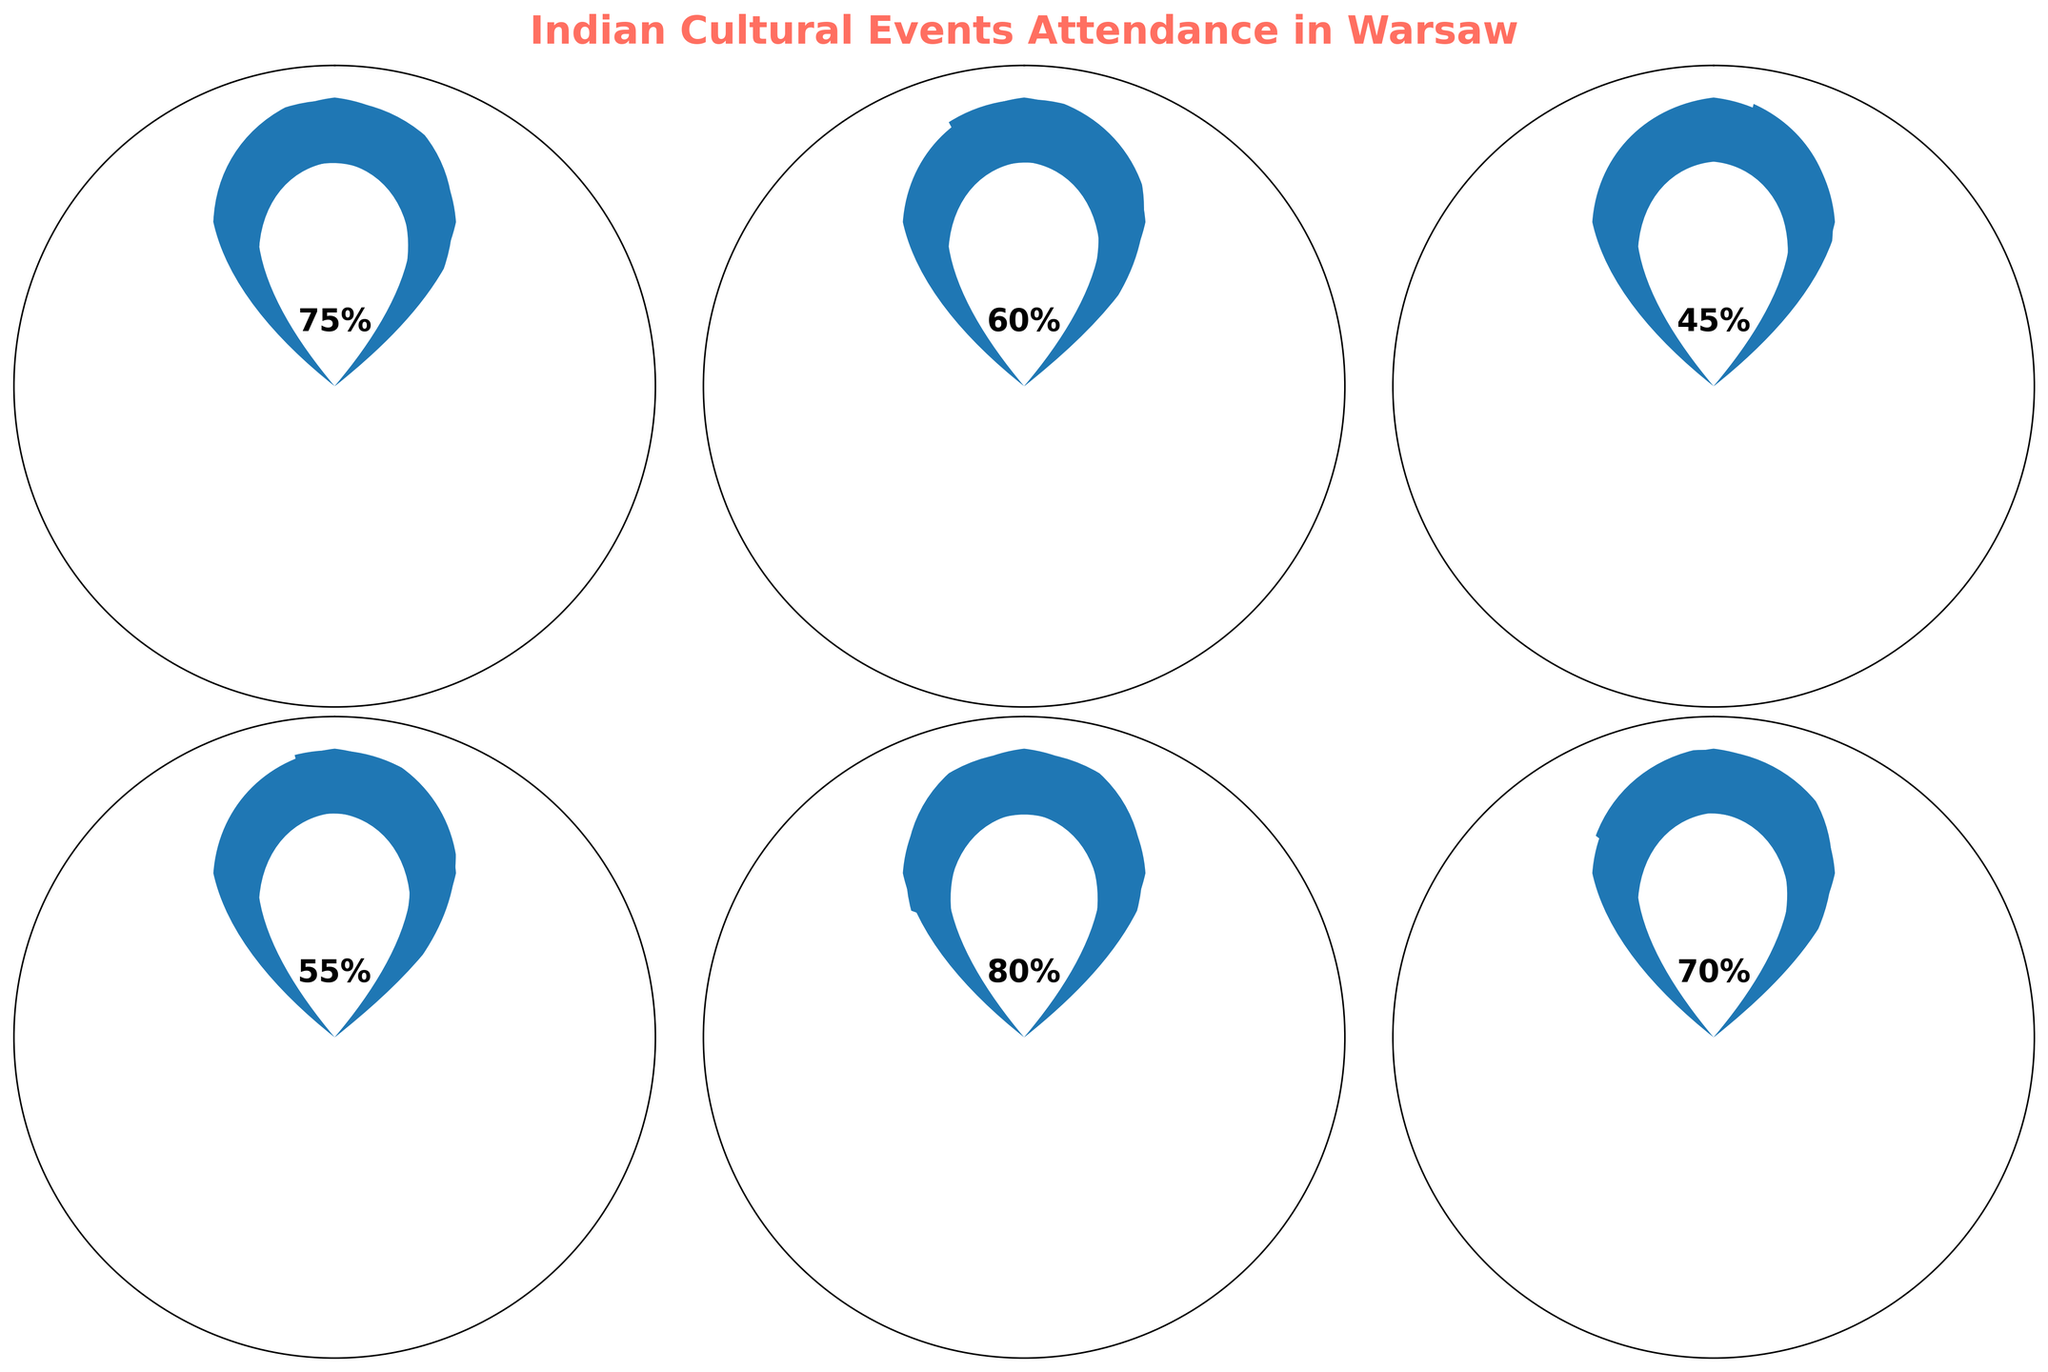What's the title of the figure? The title of the figure is shown at the top in bold and larger font. It helps identify the topic of the visualization.
Answer: Indian Cultural Events Attendance in Warsaw What is the attendance percentage for the Holi Celebration at Pole Mokotowskie? The Holi Celebration gauge shows a percentage value within the gauge. This value is displayed in bold font at the center.
Answer: 80% Which event has the lowest attendance percentage? By comparing all the gauges, the event with the smallest colored section is the Bollywood Dance Workshop.
Answer: Bollywood Dance Workshop at Centrum Kultury Wilanów What's the average attendance percentage across all events? Sum the attendance percentages: 75 + 60 + 45 + 55 + 80 + 70 = 385. Then divide by the number of events: 385 / 6 = 64.17
Answer: 64.17% How many events had an attendance percentage of 70% or higher? Identify which gauges have percentages of 70 or more, looking at the numerical values inside each gauge.
Answer: 3 Which event had a higher attendance: the Indian Film Festival or the Indian Classical Music Concert? Compare the percentages displayed within the gauges for both events.
Answer: Indian Film Festival What is the difference in attendance percentage between the Diwali Festival and the Bollywood Dance Workshop? Subtract the Bollywood Dance Workshop percentage from the Diwali Festival percentage: 75 - 45 = 30
Answer: 30 How many events are there? Count the number of individual gauges or event titles in the visualization.
Answer: 6 Which event had the second highest attendance percentage? Rank the percentages in descending order: 80, 75, 70, 60, 55, 45. The second highest percentage is 75.
Answer: Diwali Festival at University of Warsaw Is there any event with exactly 60% attendance? Look at the values inside each of the gauges to check for an exact match for 60%.
Answer: Yes 